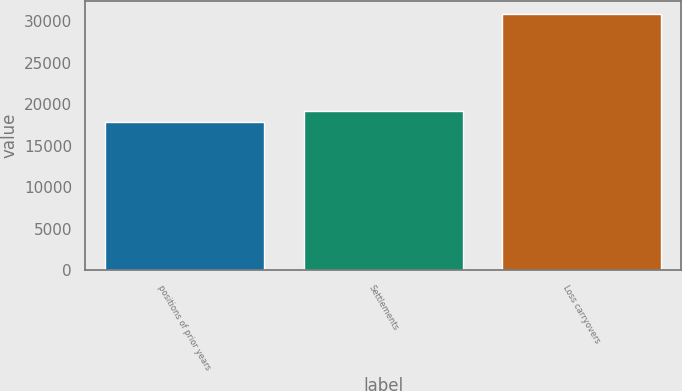Convert chart to OTSL. <chart><loc_0><loc_0><loc_500><loc_500><bar_chart><fcel>positions of prior years<fcel>Settlements<fcel>Loss carryovers<nl><fcel>17853<fcel>19159.8<fcel>30921<nl></chart> 